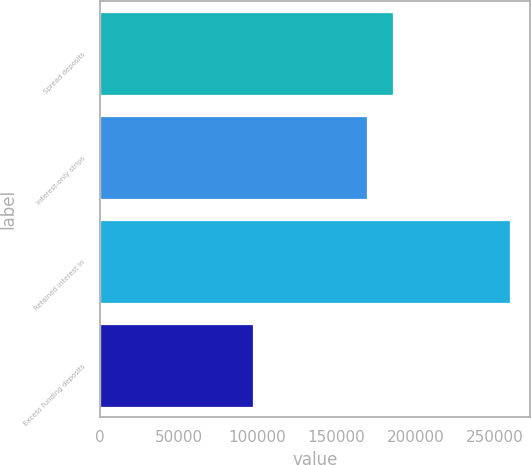Convert chart. <chart><loc_0><loc_0><loc_500><loc_500><bar_chart><fcel>Spread deposits<fcel>Interest-only strips<fcel>Retained interest in<fcel>Excess funding deposits<nl><fcel>185491<fcel>169241<fcel>259612<fcel>97110<nl></chart> 